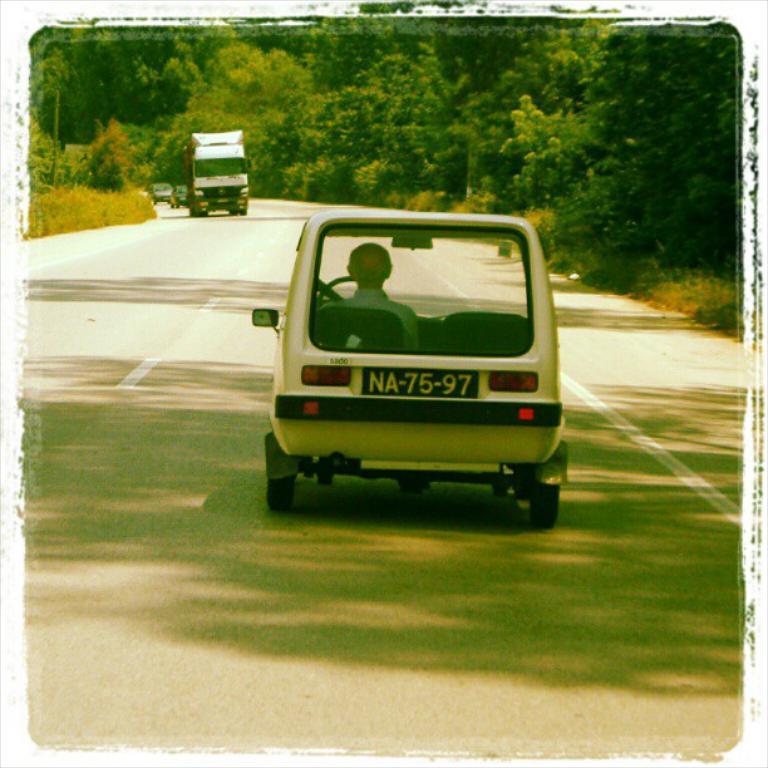Can you describe this image briefly? As we can see in the image there are cars, truck, grass and trees. 